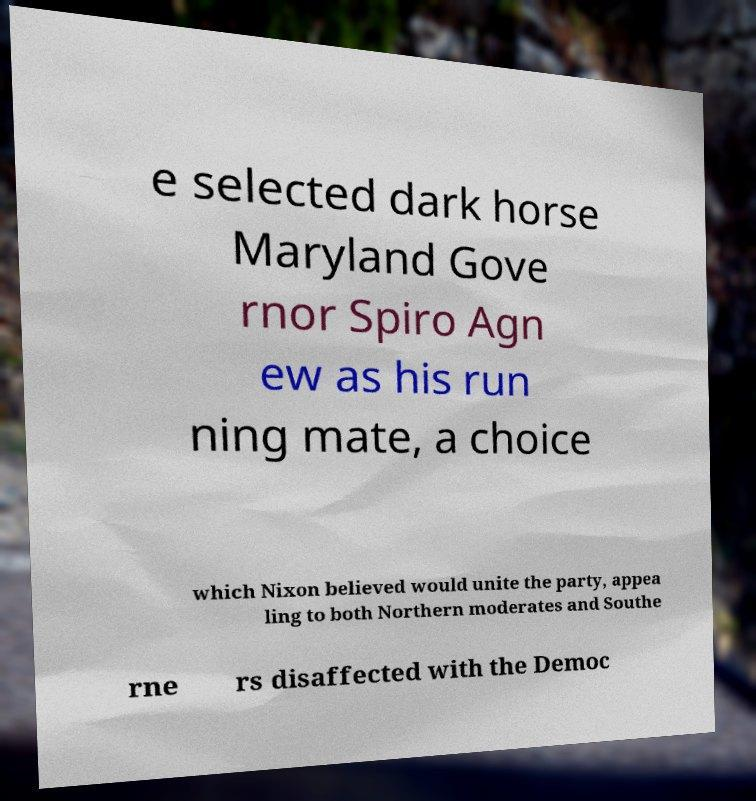Could you extract and type out the text from this image? e selected dark horse Maryland Gove rnor Spiro Agn ew as his run ning mate, a choice which Nixon believed would unite the party, appea ling to both Northern moderates and Southe rne rs disaffected with the Democ 